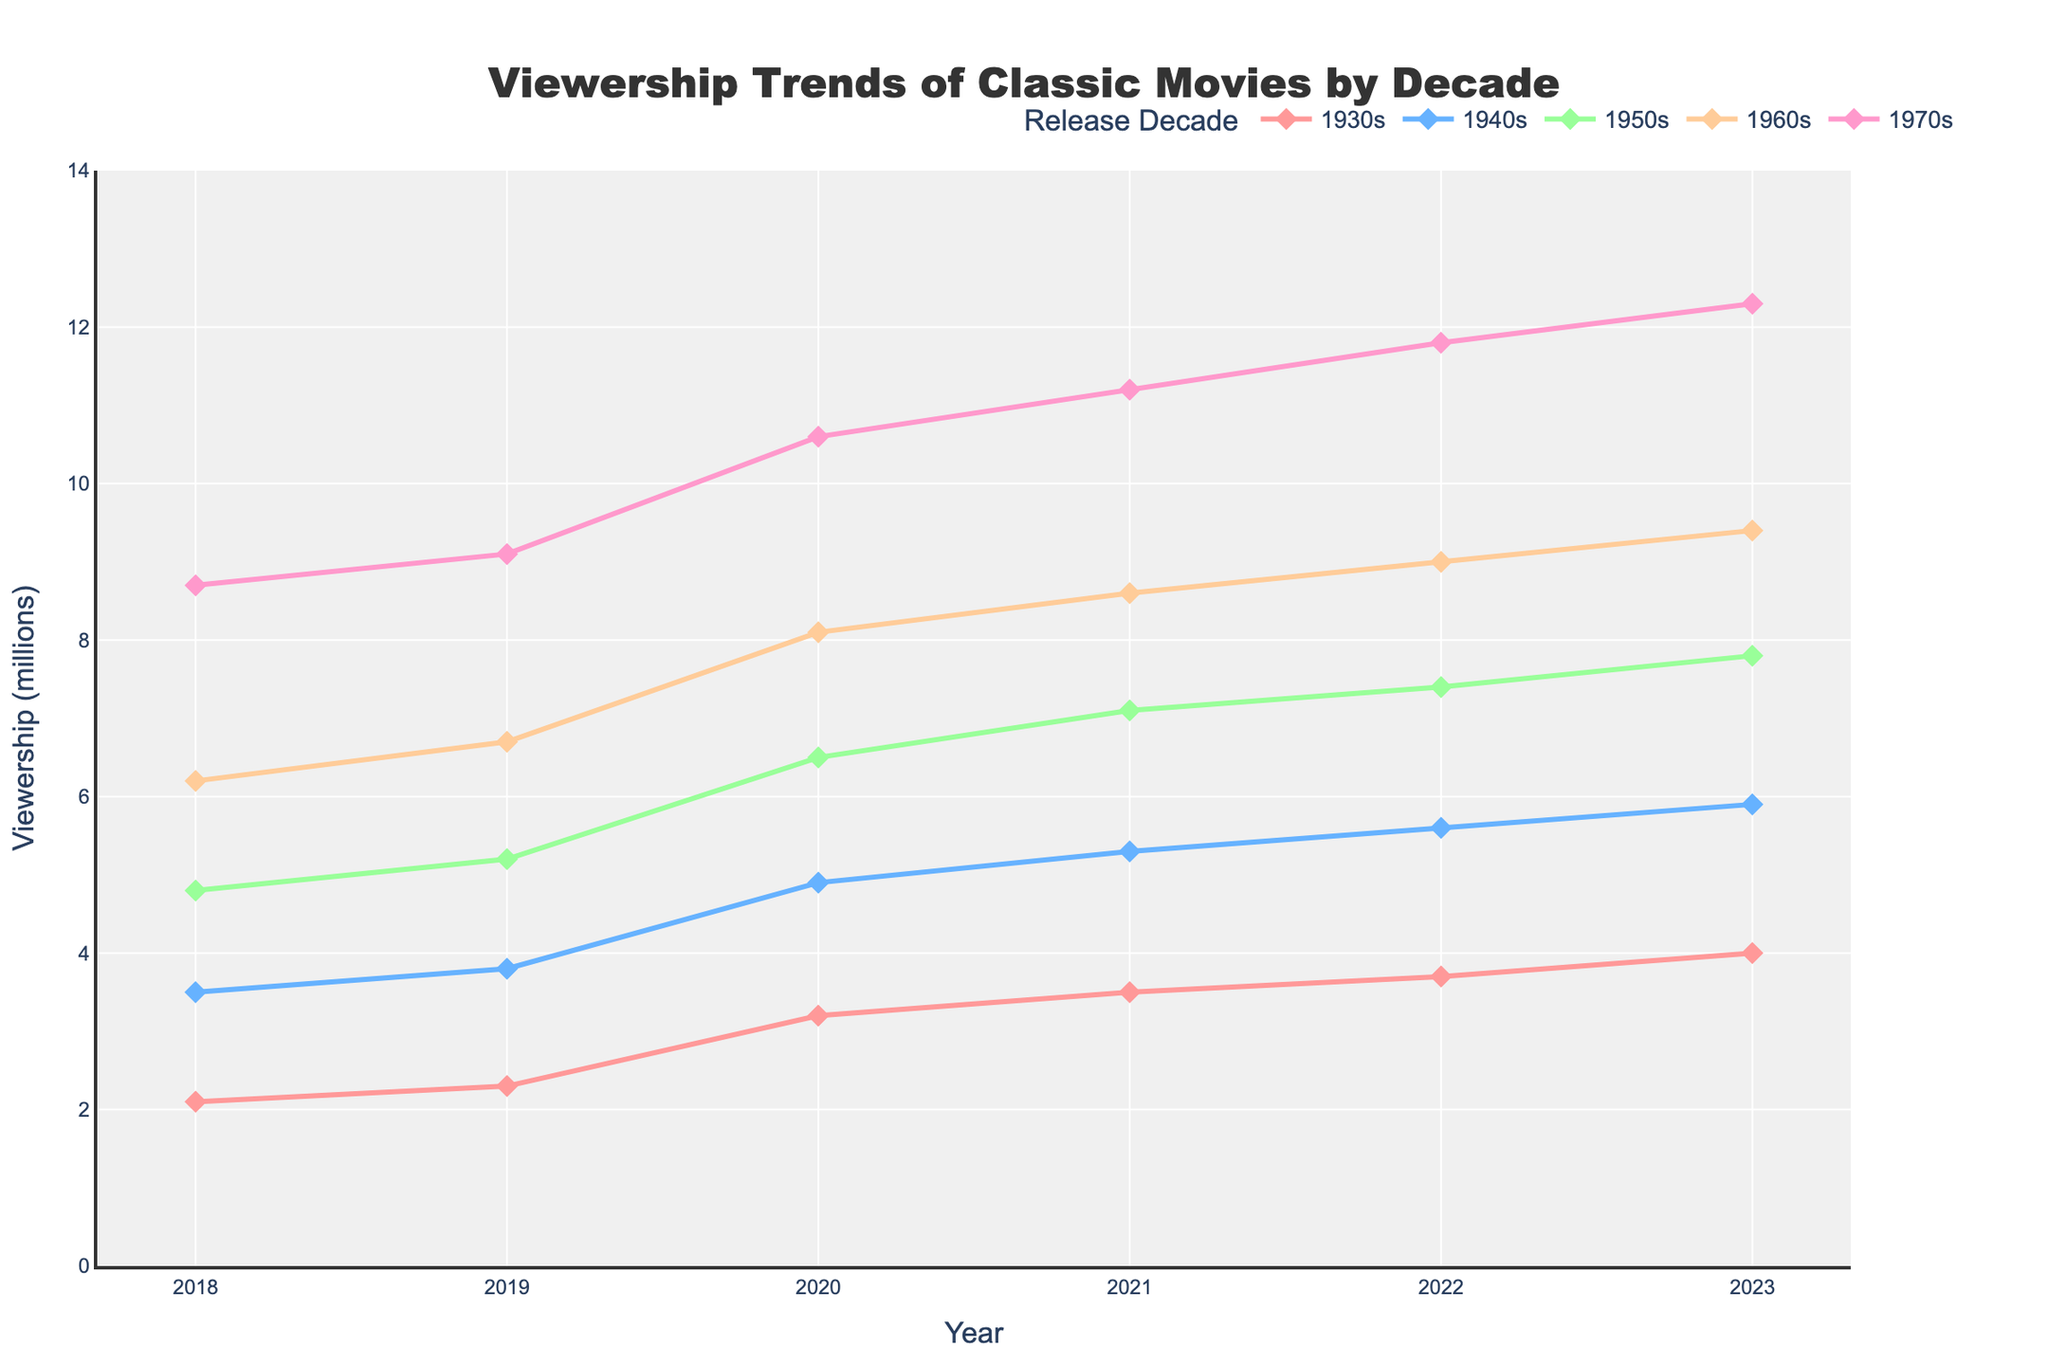What is the overall trend in viewership for 1930s films from 2018 to 2023? The viewership for 1930s films increases each year. Starting from 2.1 million in 2018, it rises to 4.0 million by 2023.
Answer: Increasing In which year did films from the 1940s surpass 5 million viewers? According to the plot, films from the 1940s surpassed 5 million viewers in 2021, rising to 5.3 million.
Answer: 2021 Which decade had the highest viewership in 2023, and what was the value? Look at the viewership values for each decade in 2023. The 1970s had the highest viewership with 12.3 million viewers.
Answer: 1970s, 12.3 million How does the viewership trend for the 1950s compare to that of the 1960s over the given period? Both decades show an increasing trend in viewership, but the 1960s consistently have higher viewership than the 1950s. The rate of increase for the 1960s is also slightly higher, particularly noticeable around 2020-2023.
Answer: Both increasing, 1960s higher What is the total viewership for all decades combined in the year 2022? Sum the viewership values for all decades in 2022:
3.7 (1930s) + 5.6 (1940s) + 7.4 (1950s) + 9.0 (1960s) + 11.8 (1970s) = 37.5 million viewers.
Answer: 37.5 million What year did the 1950s films first exceed 7 million viewers? Refer to the plot data for 1950s films and find the first year the viewership exceeds 7 million. It happens in 2021, with a viewership of 7.1 million.
Answer: 2021 